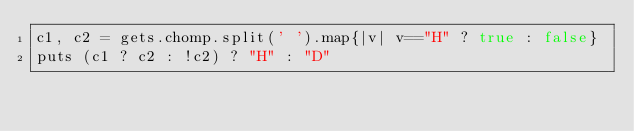<code> <loc_0><loc_0><loc_500><loc_500><_Ruby_>c1, c2 = gets.chomp.split(' ').map{|v| v=="H" ? true : false}
puts (c1 ? c2 : !c2) ? "H" : "D"
</code> 